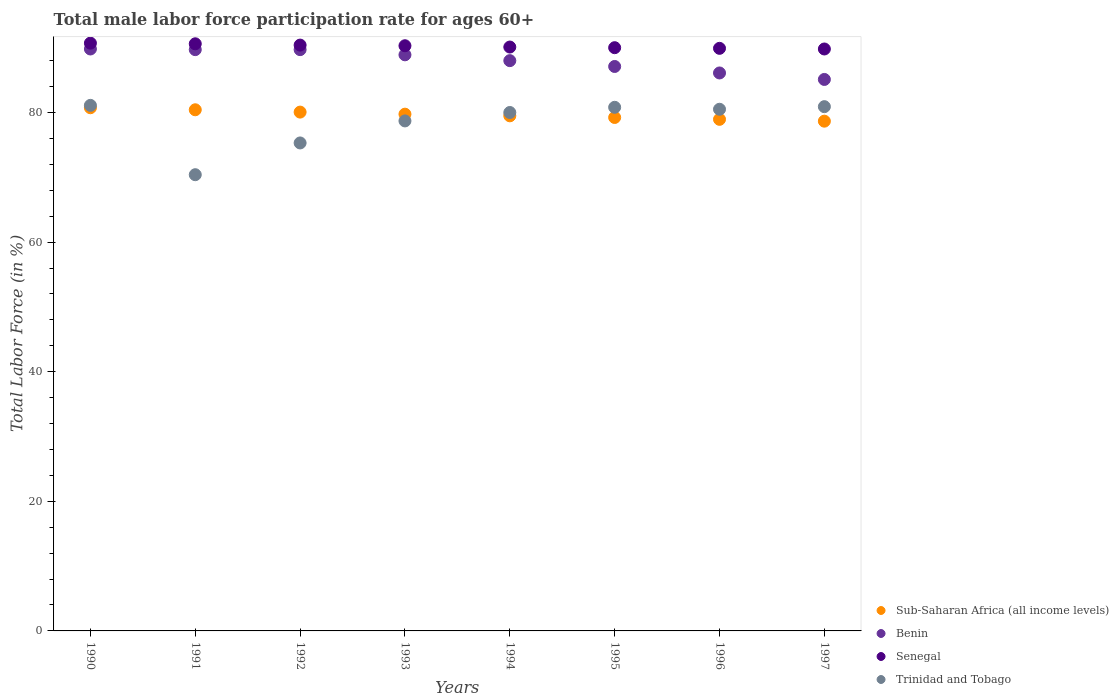Is the number of dotlines equal to the number of legend labels?
Make the answer very short. Yes. What is the male labor force participation rate in Benin in 1995?
Your answer should be compact. 87.1. Across all years, what is the maximum male labor force participation rate in Trinidad and Tobago?
Give a very brief answer. 81.1. Across all years, what is the minimum male labor force participation rate in Trinidad and Tobago?
Ensure brevity in your answer.  70.4. In which year was the male labor force participation rate in Sub-Saharan Africa (all income levels) maximum?
Offer a terse response. 1990. In which year was the male labor force participation rate in Trinidad and Tobago minimum?
Provide a succinct answer. 1991. What is the total male labor force participation rate in Trinidad and Tobago in the graph?
Make the answer very short. 627.7. What is the difference between the male labor force participation rate in Trinidad and Tobago in 1991 and that in 1992?
Make the answer very short. -4.9. What is the difference between the male labor force participation rate in Benin in 1991 and the male labor force participation rate in Trinidad and Tobago in 1990?
Your answer should be compact. 8.6. What is the average male labor force participation rate in Sub-Saharan Africa (all income levels) per year?
Keep it short and to the point. 79.66. In the year 1991, what is the difference between the male labor force participation rate in Sub-Saharan Africa (all income levels) and male labor force participation rate in Benin?
Ensure brevity in your answer.  -9.28. What is the ratio of the male labor force participation rate in Senegal in 1991 to that in 1992?
Your response must be concise. 1. Is the male labor force participation rate in Senegal in 1990 less than that in 1994?
Provide a succinct answer. No. What is the difference between the highest and the second highest male labor force participation rate in Benin?
Offer a very short reply. 0.1. What is the difference between the highest and the lowest male labor force participation rate in Benin?
Offer a very short reply. 4.7. In how many years, is the male labor force participation rate in Sub-Saharan Africa (all income levels) greater than the average male labor force participation rate in Sub-Saharan Africa (all income levels) taken over all years?
Offer a very short reply. 4. Is it the case that in every year, the sum of the male labor force participation rate in Benin and male labor force participation rate in Senegal  is greater than the male labor force participation rate in Trinidad and Tobago?
Keep it short and to the point. Yes. Is the male labor force participation rate in Sub-Saharan Africa (all income levels) strictly greater than the male labor force participation rate in Senegal over the years?
Offer a terse response. No. Is the male labor force participation rate in Trinidad and Tobago strictly less than the male labor force participation rate in Sub-Saharan Africa (all income levels) over the years?
Provide a succinct answer. No. How many dotlines are there?
Give a very brief answer. 4. How many years are there in the graph?
Make the answer very short. 8. What is the difference between two consecutive major ticks on the Y-axis?
Your response must be concise. 20. Are the values on the major ticks of Y-axis written in scientific E-notation?
Your answer should be compact. No. Does the graph contain any zero values?
Offer a very short reply. No. What is the title of the graph?
Make the answer very short. Total male labor force participation rate for ages 60+. What is the label or title of the X-axis?
Your response must be concise. Years. What is the label or title of the Y-axis?
Provide a short and direct response. Total Labor Force (in %). What is the Total Labor Force (in %) in Sub-Saharan Africa (all income levels) in 1990?
Give a very brief answer. 80.73. What is the Total Labor Force (in %) of Benin in 1990?
Provide a short and direct response. 89.8. What is the Total Labor Force (in %) in Senegal in 1990?
Offer a terse response. 90.7. What is the Total Labor Force (in %) of Trinidad and Tobago in 1990?
Make the answer very short. 81.1. What is the Total Labor Force (in %) of Sub-Saharan Africa (all income levels) in 1991?
Your answer should be very brief. 80.42. What is the Total Labor Force (in %) of Benin in 1991?
Offer a very short reply. 89.7. What is the Total Labor Force (in %) of Senegal in 1991?
Keep it short and to the point. 90.6. What is the Total Labor Force (in %) in Trinidad and Tobago in 1991?
Offer a terse response. 70.4. What is the Total Labor Force (in %) in Sub-Saharan Africa (all income levels) in 1992?
Ensure brevity in your answer.  80.06. What is the Total Labor Force (in %) in Benin in 1992?
Provide a succinct answer. 89.7. What is the Total Labor Force (in %) in Senegal in 1992?
Make the answer very short. 90.4. What is the Total Labor Force (in %) in Trinidad and Tobago in 1992?
Give a very brief answer. 75.3. What is the Total Labor Force (in %) of Sub-Saharan Africa (all income levels) in 1993?
Make the answer very short. 79.74. What is the Total Labor Force (in %) of Benin in 1993?
Offer a very short reply. 88.9. What is the Total Labor Force (in %) in Senegal in 1993?
Offer a very short reply. 90.3. What is the Total Labor Force (in %) of Trinidad and Tobago in 1993?
Offer a terse response. 78.7. What is the Total Labor Force (in %) of Sub-Saharan Africa (all income levels) in 1994?
Offer a very short reply. 79.49. What is the Total Labor Force (in %) in Benin in 1994?
Ensure brevity in your answer.  88. What is the Total Labor Force (in %) in Senegal in 1994?
Your answer should be very brief. 90.1. What is the Total Labor Force (in %) in Trinidad and Tobago in 1994?
Offer a very short reply. 80. What is the Total Labor Force (in %) in Sub-Saharan Africa (all income levels) in 1995?
Make the answer very short. 79.23. What is the Total Labor Force (in %) in Benin in 1995?
Provide a succinct answer. 87.1. What is the Total Labor Force (in %) in Trinidad and Tobago in 1995?
Make the answer very short. 80.8. What is the Total Labor Force (in %) in Sub-Saharan Africa (all income levels) in 1996?
Keep it short and to the point. 78.94. What is the Total Labor Force (in %) of Benin in 1996?
Offer a terse response. 86.1. What is the Total Labor Force (in %) in Senegal in 1996?
Provide a short and direct response. 89.9. What is the Total Labor Force (in %) of Trinidad and Tobago in 1996?
Offer a terse response. 80.5. What is the Total Labor Force (in %) of Sub-Saharan Africa (all income levels) in 1997?
Your response must be concise. 78.66. What is the Total Labor Force (in %) of Benin in 1997?
Provide a short and direct response. 85.1. What is the Total Labor Force (in %) in Senegal in 1997?
Give a very brief answer. 89.8. What is the Total Labor Force (in %) of Trinidad and Tobago in 1997?
Provide a succinct answer. 80.9. Across all years, what is the maximum Total Labor Force (in %) in Sub-Saharan Africa (all income levels)?
Your answer should be very brief. 80.73. Across all years, what is the maximum Total Labor Force (in %) of Benin?
Offer a very short reply. 89.8. Across all years, what is the maximum Total Labor Force (in %) of Senegal?
Offer a terse response. 90.7. Across all years, what is the maximum Total Labor Force (in %) of Trinidad and Tobago?
Keep it short and to the point. 81.1. Across all years, what is the minimum Total Labor Force (in %) of Sub-Saharan Africa (all income levels)?
Keep it short and to the point. 78.66. Across all years, what is the minimum Total Labor Force (in %) in Benin?
Keep it short and to the point. 85.1. Across all years, what is the minimum Total Labor Force (in %) in Senegal?
Keep it short and to the point. 89.8. Across all years, what is the minimum Total Labor Force (in %) of Trinidad and Tobago?
Your answer should be compact. 70.4. What is the total Total Labor Force (in %) of Sub-Saharan Africa (all income levels) in the graph?
Give a very brief answer. 637.27. What is the total Total Labor Force (in %) of Benin in the graph?
Keep it short and to the point. 704.4. What is the total Total Labor Force (in %) of Senegal in the graph?
Your response must be concise. 721.8. What is the total Total Labor Force (in %) in Trinidad and Tobago in the graph?
Give a very brief answer. 627.7. What is the difference between the Total Labor Force (in %) in Sub-Saharan Africa (all income levels) in 1990 and that in 1991?
Make the answer very short. 0.31. What is the difference between the Total Labor Force (in %) of Benin in 1990 and that in 1991?
Provide a succinct answer. 0.1. What is the difference between the Total Labor Force (in %) in Sub-Saharan Africa (all income levels) in 1990 and that in 1992?
Make the answer very short. 0.67. What is the difference between the Total Labor Force (in %) of Benin in 1990 and that in 1992?
Offer a very short reply. 0.1. What is the difference between the Total Labor Force (in %) in Senegal in 1990 and that in 1992?
Your answer should be very brief. 0.3. What is the difference between the Total Labor Force (in %) of Benin in 1990 and that in 1993?
Give a very brief answer. 0.9. What is the difference between the Total Labor Force (in %) in Senegal in 1990 and that in 1993?
Keep it short and to the point. 0.4. What is the difference between the Total Labor Force (in %) of Sub-Saharan Africa (all income levels) in 1990 and that in 1994?
Make the answer very short. 1.25. What is the difference between the Total Labor Force (in %) of Trinidad and Tobago in 1990 and that in 1994?
Your answer should be very brief. 1.1. What is the difference between the Total Labor Force (in %) of Sub-Saharan Africa (all income levels) in 1990 and that in 1995?
Make the answer very short. 1.5. What is the difference between the Total Labor Force (in %) in Benin in 1990 and that in 1995?
Provide a succinct answer. 2.7. What is the difference between the Total Labor Force (in %) in Senegal in 1990 and that in 1995?
Offer a very short reply. 0.7. What is the difference between the Total Labor Force (in %) in Sub-Saharan Africa (all income levels) in 1990 and that in 1996?
Your response must be concise. 1.79. What is the difference between the Total Labor Force (in %) in Benin in 1990 and that in 1996?
Provide a succinct answer. 3.7. What is the difference between the Total Labor Force (in %) of Senegal in 1990 and that in 1996?
Provide a succinct answer. 0.8. What is the difference between the Total Labor Force (in %) of Sub-Saharan Africa (all income levels) in 1990 and that in 1997?
Offer a terse response. 2.07. What is the difference between the Total Labor Force (in %) of Senegal in 1990 and that in 1997?
Offer a very short reply. 0.9. What is the difference between the Total Labor Force (in %) in Trinidad and Tobago in 1990 and that in 1997?
Your answer should be very brief. 0.2. What is the difference between the Total Labor Force (in %) of Sub-Saharan Africa (all income levels) in 1991 and that in 1992?
Provide a short and direct response. 0.36. What is the difference between the Total Labor Force (in %) of Benin in 1991 and that in 1992?
Your answer should be very brief. 0. What is the difference between the Total Labor Force (in %) in Senegal in 1991 and that in 1992?
Offer a terse response. 0.2. What is the difference between the Total Labor Force (in %) of Trinidad and Tobago in 1991 and that in 1992?
Your answer should be compact. -4.9. What is the difference between the Total Labor Force (in %) in Sub-Saharan Africa (all income levels) in 1991 and that in 1993?
Your response must be concise. 0.68. What is the difference between the Total Labor Force (in %) of Senegal in 1991 and that in 1993?
Keep it short and to the point. 0.3. What is the difference between the Total Labor Force (in %) of Trinidad and Tobago in 1991 and that in 1993?
Give a very brief answer. -8.3. What is the difference between the Total Labor Force (in %) of Sub-Saharan Africa (all income levels) in 1991 and that in 1994?
Make the answer very short. 0.93. What is the difference between the Total Labor Force (in %) of Trinidad and Tobago in 1991 and that in 1994?
Provide a short and direct response. -9.6. What is the difference between the Total Labor Force (in %) in Sub-Saharan Africa (all income levels) in 1991 and that in 1995?
Provide a short and direct response. 1.19. What is the difference between the Total Labor Force (in %) in Senegal in 1991 and that in 1995?
Your answer should be compact. 0.6. What is the difference between the Total Labor Force (in %) of Sub-Saharan Africa (all income levels) in 1991 and that in 1996?
Offer a very short reply. 1.48. What is the difference between the Total Labor Force (in %) in Benin in 1991 and that in 1996?
Your answer should be very brief. 3.6. What is the difference between the Total Labor Force (in %) in Sub-Saharan Africa (all income levels) in 1991 and that in 1997?
Your answer should be very brief. 1.76. What is the difference between the Total Labor Force (in %) in Senegal in 1991 and that in 1997?
Your answer should be compact. 0.8. What is the difference between the Total Labor Force (in %) of Trinidad and Tobago in 1991 and that in 1997?
Provide a succinct answer. -10.5. What is the difference between the Total Labor Force (in %) in Sub-Saharan Africa (all income levels) in 1992 and that in 1993?
Offer a terse response. 0.32. What is the difference between the Total Labor Force (in %) in Benin in 1992 and that in 1993?
Give a very brief answer. 0.8. What is the difference between the Total Labor Force (in %) in Sub-Saharan Africa (all income levels) in 1992 and that in 1994?
Provide a succinct answer. 0.57. What is the difference between the Total Labor Force (in %) in Benin in 1992 and that in 1994?
Make the answer very short. 1.7. What is the difference between the Total Labor Force (in %) of Senegal in 1992 and that in 1994?
Keep it short and to the point. 0.3. What is the difference between the Total Labor Force (in %) of Sub-Saharan Africa (all income levels) in 1992 and that in 1995?
Give a very brief answer. 0.83. What is the difference between the Total Labor Force (in %) of Senegal in 1992 and that in 1995?
Offer a very short reply. 0.4. What is the difference between the Total Labor Force (in %) of Trinidad and Tobago in 1992 and that in 1995?
Give a very brief answer. -5.5. What is the difference between the Total Labor Force (in %) of Sub-Saharan Africa (all income levels) in 1992 and that in 1996?
Provide a short and direct response. 1.12. What is the difference between the Total Labor Force (in %) in Senegal in 1992 and that in 1996?
Your answer should be very brief. 0.5. What is the difference between the Total Labor Force (in %) of Trinidad and Tobago in 1992 and that in 1996?
Offer a terse response. -5.2. What is the difference between the Total Labor Force (in %) in Sub-Saharan Africa (all income levels) in 1992 and that in 1997?
Your answer should be very brief. 1.4. What is the difference between the Total Labor Force (in %) in Sub-Saharan Africa (all income levels) in 1993 and that in 1994?
Your response must be concise. 0.25. What is the difference between the Total Labor Force (in %) of Senegal in 1993 and that in 1994?
Offer a very short reply. 0.2. What is the difference between the Total Labor Force (in %) of Sub-Saharan Africa (all income levels) in 1993 and that in 1995?
Give a very brief answer. 0.51. What is the difference between the Total Labor Force (in %) in Benin in 1993 and that in 1995?
Your response must be concise. 1.8. What is the difference between the Total Labor Force (in %) in Senegal in 1993 and that in 1995?
Provide a short and direct response. 0.3. What is the difference between the Total Labor Force (in %) of Trinidad and Tobago in 1993 and that in 1995?
Your answer should be compact. -2.1. What is the difference between the Total Labor Force (in %) in Sub-Saharan Africa (all income levels) in 1993 and that in 1996?
Ensure brevity in your answer.  0.8. What is the difference between the Total Labor Force (in %) in Senegal in 1993 and that in 1996?
Make the answer very short. 0.4. What is the difference between the Total Labor Force (in %) in Sub-Saharan Africa (all income levels) in 1993 and that in 1997?
Ensure brevity in your answer.  1.08. What is the difference between the Total Labor Force (in %) of Trinidad and Tobago in 1993 and that in 1997?
Provide a succinct answer. -2.2. What is the difference between the Total Labor Force (in %) in Sub-Saharan Africa (all income levels) in 1994 and that in 1995?
Ensure brevity in your answer.  0.25. What is the difference between the Total Labor Force (in %) in Benin in 1994 and that in 1995?
Offer a terse response. 0.9. What is the difference between the Total Labor Force (in %) of Trinidad and Tobago in 1994 and that in 1995?
Keep it short and to the point. -0.8. What is the difference between the Total Labor Force (in %) in Sub-Saharan Africa (all income levels) in 1994 and that in 1996?
Your answer should be very brief. 0.54. What is the difference between the Total Labor Force (in %) in Benin in 1994 and that in 1996?
Your answer should be compact. 1.9. What is the difference between the Total Labor Force (in %) of Senegal in 1994 and that in 1996?
Ensure brevity in your answer.  0.2. What is the difference between the Total Labor Force (in %) of Trinidad and Tobago in 1994 and that in 1996?
Offer a terse response. -0.5. What is the difference between the Total Labor Force (in %) of Sub-Saharan Africa (all income levels) in 1994 and that in 1997?
Give a very brief answer. 0.82. What is the difference between the Total Labor Force (in %) in Benin in 1994 and that in 1997?
Give a very brief answer. 2.9. What is the difference between the Total Labor Force (in %) of Senegal in 1994 and that in 1997?
Your answer should be very brief. 0.3. What is the difference between the Total Labor Force (in %) of Trinidad and Tobago in 1994 and that in 1997?
Offer a very short reply. -0.9. What is the difference between the Total Labor Force (in %) in Sub-Saharan Africa (all income levels) in 1995 and that in 1996?
Provide a short and direct response. 0.29. What is the difference between the Total Labor Force (in %) in Senegal in 1995 and that in 1996?
Keep it short and to the point. 0.1. What is the difference between the Total Labor Force (in %) in Sub-Saharan Africa (all income levels) in 1995 and that in 1997?
Your answer should be very brief. 0.57. What is the difference between the Total Labor Force (in %) of Benin in 1995 and that in 1997?
Offer a very short reply. 2. What is the difference between the Total Labor Force (in %) of Trinidad and Tobago in 1995 and that in 1997?
Make the answer very short. -0.1. What is the difference between the Total Labor Force (in %) of Sub-Saharan Africa (all income levels) in 1996 and that in 1997?
Provide a succinct answer. 0.28. What is the difference between the Total Labor Force (in %) in Benin in 1996 and that in 1997?
Ensure brevity in your answer.  1. What is the difference between the Total Labor Force (in %) in Trinidad and Tobago in 1996 and that in 1997?
Provide a succinct answer. -0.4. What is the difference between the Total Labor Force (in %) of Sub-Saharan Africa (all income levels) in 1990 and the Total Labor Force (in %) of Benin in 1991?
Give a very brief answer. -8.97. What is the difference between the Total Labor Force (in %) in Sub-Saharan Africa (all income levels) in 1990 and the Total Labor Force (in %) in Senegal in 1991?
Make the answer very short. -9.87. What is the difference between the Total Labor Force (in %) in Sub-Saharan Africa (all income levels) in 1990 and the Total Labor Force (in %) in Trinidad and Tobago in 1991?
Offer a very short reply. 10.33. What is the difference between the Total Labor Force (in %) of Benin in 1990 and the Total Labor Force (in %) of Trinidad and Tobago in 1991?
Provide a succinct answer. 19.4. What is the difference between the Total Labor Force (in %) in Senegal in 1990 and the Total Labor Force (in %) in Trinidad and Tobago in 1991?
Your answer should be compact. 20.3. What is the difference between the Total Labor Force (in %) in Sub-Saharan Africa (all income levels) in 1990 and the Total Labor Force (in %) in Benin in 1992?
Keep it short and to the point. -8.97. What is the difference between the Total Labor Force (in %) in Sub-Saharan Africa (all income levels) in 1990 and the Total Labor Force (in %) in Senegal in 1992?
Ensure brevity in your answer.  -9.67. What is the difference between the Total Labor Force (in %) of Sub-Saharan Africa (all income levels) in 1990 and the Total Labor Force (in %) of Trinidad and Tobago in 1992?
Provide a short and direct response. 5.43. What is the difference between the Total Labor Force (in %) in Benin in 1990 and the Total Labor Force (in %) in Senegal in 1992?
Keep it short and to the point. -0.6. What is the difference between the Total Labor Force (in %) of Sub-Saharan Africa (all income levels) in 1990 and the Total Labor Force (in %) of Benin in 1993?
Give a very brief answer. -8.17. What is the difference between the Total Labor Force (in %) of Sub-Saharan Africa (all income levels) in 1990 and the Total Labor Force (in %) of Senegal in 1993?
Your answer should be compact. -9.57. What is the difference between the Total Labor Force (in %) of Sub-Saharan Africa (all income levels) in 1990 and the Total Labor Force (in %) of Trinidad and Tobago in 1993?
Your response must be concise. 2.03. What is the difference between the Total Labor Force (in %) in Benin in 1990 and the Total Labor Force (in %) in Senegal in 1993?
Offer a terse response. -0.5. What is the difference between the Total Labor Force (in %) of Sub-Saharan Africa (all income levels) in 1990 and the Total Labor Force (in %) of Benin in 1994?
Offer a very short reply. -7.27. What is the difference between the Total Labor Force (in %) of Sub-Saharan Africa (all income levels) in 1990 and the Total Labor Force (in %) of Senegal in 1994?
Your answer should be compact. -9.37. What is the difference between the Total Labor Force (in %) of Sub-Saharan Africa (all income levels) in 1990 and the Total Labor Force (in %) of Trinidad and Tobago in 1994?
Your answer should be very brief. 0.73. What is the difference between the Total Labor Force (in %) of Benin in 1990 and the Total Labor Force (in %) of Senegal in 1994?
Provide a short and direct response. -0.3. What is the difference between the Total Labor Force (in %) of Sub-Saharan Africa (all income levels) in 1990 and the Total Labor Force (in %) of Benin in 1995?
Ensure brevity in your answer.  -6.37. What is the difference between the Total Labor Force (in %) of Sub-Saharan Africa (all income levels) in 1990 and the Total Labor Force (in %) of Senegal in 1995?
Provide a succinct answer. -9.27. What is the difference between the Total Labor Force (in %) in Sub-Saharan Africa (all income levels) in 1990 and the Total Labor Force (in %) in Trinidad and Tobago in 1995?
Offer a terse response. -0.07. What is the difference between the Total Labor Force (in %) of Benin in 1990 and the Total Labor Force (in %) of Trinidad and Tobago in 1995?
Your answer should be compact. 9. What is the difference between the Total Labor Force (in %) in Senegal in 1990 and the Total Labor Force (in %) in Trinidad and Tobago in 1995?
Provide a succinct answer. 9.9. What is the difference between the Total Labor Force (in %) of Sub-Saharan Africa (all income levels) in 1990 and the Total Labor Force (in %) of Benin in 1996?
Offer a terse response. -5.37. What is the difference between the Total Labor Force (in %) of Sub-Saharan Africa (all income levels) in 1990 and the Total Labor Force (in %) of Senegal in 1996?
Provide a succinct answer. -9.17. What is the difference between the Total Labor Force (in %) in Sub-Saharan Africa (all income levels) in 1990 and the Total Labor Force (in %) in Trinidad and Tobago in 1996?
Provide a short and direct response. 0.23. What is the difference between the Total Labor Force (in %) in Benin in 1990 and the Total Labor Force (in %) in Senegal in 1996?
Your answer should be very brief. -0.1. What is the difference between the Total Labor Force (in %) of Senegal in 1990 and the Total Labor Force (in %) of Trinidad and Tobago in 1996?
Provide a succinct answer. 10.2. What is the difference between the Total Labor Force (in %) in Sub-Saharan Africa (all income levels) in 1990 and the Total Labor Force (in %) in Benin in 1997?
Offer a terse response. -4.37. What is the difference between the Total Labor Force (in %) of Sub-Saharan Africa (all income levels) in 1990 and the Total Labor Force (in %) of Senegal in 1997?
Offer a terse response. -9.07. What is the difference between the Total Labor Force (in %) of Sub-Saharan Africa (all income levels) in 1990 and the Total Labor Force (in %) of Trinidad and Tobago in 1997?
Provide a succinct answer. -0.17. What is the difference between the Total Labor Force (in %) in Benin in 1990 and the Total Labor Force (in %) in Senegal in 1997?
Your answer should be compact. 0. What is the difference between the Total Labor Force (in %) of Senegal in 1990 and the Total Labor Force (in %) of Trinidad and Tobago in 1997?
Make the answer very short. 9.8. What is the difference between the Total Labor Force (in %) in Sub-Saharan Africa (all income levels) in 1991 and the Total Labor Force (in %) in Benin in 1992?
Offer a terse response. -9.28. What is the difference between the Total Labor Force (in %) of Sub-Saharan Africa (all income levels) in 1991 and the Total Labor Force (in %) of Senegal in 1992?
Your response must be concise. -9.98. What is the difference between the Total Labor Force (in %) in Sub-Saharan Africa (all income levels) in 1991 and the Total Labor Force (in %) in Trinidad and Tobago in 1992?
Ensure brevity in your answer.  5.12. What is the difference between the Total Labor Force (in %) in Benin in 1991 and the Total Labor Force (in %) in Senegal in 1992?
Keep it short and to the point. -0.7. What is the difference between the Total Labor Force (in %) of Sub-Saharan Africa (all income levels) in 1991 and the Total Labor Force (in %) of Benin in 1993?
Make the answer very short. -8.48. What is the difference between the Total Labor Force (in %) in Sub-Saharan Africa (all income levels) in 1991 and the Total Labor Force (in %) in Senegal in 1993?
Offer a very short reply. -9.88. What is the difference between the Total Labor Force (in %) of Sub-Saharan Africa (all income levels) in 1991 and the Total Labor Force (in %) of Trinidad and Tobago in 1993?
Provide a short and direct response. 1.72. What is the difference between the Total Labor Force (in %) in Benin in 1991 and the Total Labor Force (in %) in Senegal in 1993?
Make the answer very short. -0.6. What is the difference between the Total Labor Force (in %) in Benin in 1991 and the Total Labor Force (in %) in Trinidad and Tobago in 1993?
Give a very brief answer. 11. What is the difference between the Total Labor Force (in %) of Senegal in 1991 and the Total Labor Force (in %) of Trinidad and Tobago in 1993?
Offer a very short reply. 11.9. What is the difference between the Total Labor Force (in %) in Sub-Saharan Africa (all income levels) in 1991 and the Total Labor Force (in %) in Benin in 1994?
Provide a succinct answer. -7.58. What is the difference between the Total Labor Force (in %) of Sub-Saharan Africa (all income levels) in 1991 and the Total Labor Force (in %) of Senegal in 1994?
Make the answer very short. -9.68. What is the difference between the Total Labor Force (in %) in Sub-Saharan Africa (all income levels) in 1991 and the Total Labor Force (in %) in Trinidad and Tobago in 1994?
Give a very brief answer. 0.42. What is the difference between the Total Labor Force (in %) in Benin in 1991 and the Total Labor Force (in %) in Trinidad and Tobago in 1994?
Give a very brief answer. 9.7. What is the difference between the Total Labor Force (in %) of Senegal in 1991 and the Total Labor Force (in %) of Trinidad and Tobago in 1994?
Keep it short and to the point. 10.6. What is the difference between the Total Labor Force (in %) of Sub-Saharan Africa (all income levels) in 1991 and the Total Labor Force (in %) of Benin in 1995?
Your response must be concise. -6.68. What is the difference between the Total Labor Force (in %) in Sub-Saharan Africa (all income levels) in 1991 and the Total Labor Force (in %) in Senegal in 1995?
Provide a short and direct response. -9.58. What is the difference between the Total Labor Force (in %) in Sub-Saharan Africa (all income levels) in 1991 and the Total Labor Force (in %) in Trinidad and Tobago in 1995?
Offer a terse response. -0.38. What is the difference between the Total Labor Force (in %) in Benin in 1991 and the Total Labor Force (in %) in Senegal in 1995?
Offer a terse response. -0.3. What is the difference between the Total Labor Force (in %) in Senegal in 1991 and the Total Labor Force (in %) in Trinidad and Tobago in 1995?
Your answer should be very brief. 9.8. What is the difference between the Total Labor Force (in %) of Sub-Saharan Africa (all income levels) in 1991 and the Total Labor Force (in %) of Benin in 1996?
Your answer should be compact. -5.68. What is the difference between the Total Labor Force (in %) of Sub-Saharan Africa (all income levels) in 1991 and the Total Labor Force (in %) of Senegal in 1996?
Give a very brief answer. -9.48. What is the difference between the Total Labor Force (in %) of Sub-Saharan Africa (all income levels) in 1991 and the Total Labor Force (in %) of Trinidad and Tobago in 1996?
Offer a very short reply. -0.08. What is the difference between the Total Labor Force (in %) in Sub-Saharan Africa (all income levels) in 1991 and the Total Labor Force (in %) in Benin in 1997?
Provide a succinct answer. -4.68. What is the difference between the Total Labor Force (in %) in Sub-Saharan Africa (all income levels) in 1991 and the Total Labor Force (in %) in Senegal in 1997?
Make the answer very short. -9.38. What is the difference between the Total Labor Force (in %) in Sub-Saharan Africa (all income levels) in 1991 and the Total Labor Force (in %) in Trinidad and Tobago in 1997?
Your answer should be very brief. -0.48. What is the difference between the Total Labor Force (in %) in Benin in 1991 and the Total Labor Force (in %) in Senegal in 1997?
Give a very brief answer. -0.1. What is the difference between the Total Labor Force (in %) of Senegal in 1991 and the Total Labor Force (in %) of Trinidad and Tobago in 1997?
Offer a terse response. 9.7. What is the difference between the Total Labor Force (in %) of Sub-Saharan Africa (all income levels) in 1992 and the Total Labor Force (in %) of Benin in 1993?
Offer a very short reply. -8.84. What is the difference between the Total Labor Force (in %) of Sub-Saharan Africa (all income levels) in 1992 and the Total Labor Force (in %) of Senegal in 1993?
Ensure brevity in your answer.  -10.24. What is the difference between the Total Labor Force (in %) of Sub-Saharan Africa (all income levels) in 1992 and the Total Labor Force (in %) of Trinidad and Tobago in 1993?
Make the answer very short. 1.36. What is the difference between the Total Labor Force (in %) in Benin in 1992 and the Total Labor Force (in %) in Senegal in 1993?
Ensure brevity in your answer.  -0.6. What is the difference between the Total Labor Force (in %) of Benin in 1992 and the Total Labor Force (in %) of Trinidad and Tobago in 1993?
Offer a very short reply. 11. What is the difference between the Total Labor Force (in %) in Senegal in 1992 and the Total Labor Force (in %) in Trinidad and Tobago in 1993?
Keep it short and to the point. 11.7. What is the difference between the Total Labor Force (in %) in Sub-Saharan Africa (all income levels) in 1992 and the Total Labor Force (in %) in Benin in 1994?
Keep it short and to the point. -7.94. What is the difference between the Total Labor Force (in %) of Sub-Saharan Africa (all income levels) in 1992 and the Total Labor Force (in %) of Senegal in 1994?
Your answer should be compact. -10.04. What is the difference between the Total Labor Force (in %) in Sub-Saharan Africa (all income levels) in 1992 and the Total Labor Force (in %) in Trinidad and Tobago in 1994?
Your answer should be compact. 0.06. What is the difference between the Total Labor Force (in %) of Senegal in 1992 and the Total Labor Force (in %) of Trinidad and Tobago in 1994?
Your response must be concise. 10.4. What is the difference between the Total Labor Force (in %) in Sub-Saharan Africa (all income levels) in 1992 and the Total Labor Force (in %) in Benin in 1995?
Offer a terse response. -7.04. What is the difference between the Total Labor Force (in %) in Sub-Saharan Africa (all income levels) in 1992 and the Total Labor Force (in %) in Senegal in 1995?
Offer a very short reply. -9.94. What is the difference between the Total Labor Force (in %) in Sub-Saharan Africa (all income levels) in 1992 and the Total Labor Force (in %) in Trinidad and Tobago in 1995?
Give a very brief answer. -0.74. What is the difference between the Total Labor Force (in %) in Sub-Saharan Africa (all income levels) in 1992 and the Total Labor Force (in %) in Benin in 1996?
Give a very brief answer. -6.04. What is the difference between the Total Labor Force (in %) in Sub-Saharan Africa (all income levels) in 1992 and the Total Labor Force (in %) in Senegal in 1996?
Provide a short and direct response. -9.84. What is the difference between the Total Labor Force (in %) in Sub-Saharan Africa (all income levels) in 1992 and the Total Labor Force (in %) in Trinidad and Tobago in 1996?
Offer a terse response. -0.44. What is the difference between the Total Labor Force (in %) of Benin in 1992 and the Total Labor Force (in %) of Trinidad and Tobago in 1996?
Offer a terse response. 9.2. What is the difference between the Total Labor Force (in %) of Sub-Saharan Africa (all income levels) in 1992 and the Total Labor Force (in %) of Benin in 1997?
Your answer should be compact. -5.04. What is the difference between the Total Labor Force (in %) of Sub-Saharan Africa (all income levels) in 1992 and the Total Labor Force (in %) of Senegal in 1997?
Your response must be concise. -9.74. What is the difference between the Total Labor Force (in %) of Sub-Saharan Africa (all income levels) in 1992 and the Total Labor Force (in %) of Trinidad and Tobago in 1997?
Provide a short and direct response. -0.84. What is the difference between the Total Labor Force (in %) in Benin in 1992 and the Total Labor Force (in %) in Trinidad and Tobago in 1997?
Provide a succinct answer. 8.8. What is the difference between the Total Labor Force (in %) of Sub-Saharan Africa (all income levels) in 1993 and the Total Labor Force (in %) of Benin in 1994?
Your answer should be very brief. -8.26. What is the difference between the Total Labor Force (in %) of Sub-Saharan Africa (all income levels) in 1993 and the Total Labor Force (in %) of Senegal in 1994?
Offer a very short reply. -10.36. What is the difference between the Total Labor Force (in %) of Sub-Saharan Africa (all income levels) in 1993 and the Total Labor Force (in %) of Trinidad and Tobago in 1994?
Provide a short and direct response. -0.26. What is the difference between the Total Labor Force (in %) in Benin in 1993 and the Total Labor Force (in %) in Senegal in 1994?
Provide a succinct answer. -1.2. What is the difference between the Total Labor Force (in %) of Benin in 1993 and the Total Labor Force (in %) of Trinidad and Tobago in 1994?
Offer a terse response. 8.9. What is the difference between the Total Labor Force (in %) in Sub-Saharan Africa (all income levels) in 1993 and the Total Labor Force (in %) in Benin in 1995?
Offer a very short reply. -7.36. What is the difference between the Total Labor Force (in %) of Sub-Saharan Africa (all income levels) in 1993 and the Total Labor Force (in %) of Senegal in 1995?
Offer a very short reply. -10.26. What is the difference between the Total Labor Force (in %) of Sub-Saharan Africa (all income levels) in 1993 and the Total Labor Force (in %) of Trinidad and Tobago in 1995?
Ensure brevity in your answer.  -1.06. What is the difference between the Total Labor Force (in %) of Sub-Saharan Africa (all income levels) in 1993 and the Total Labor Force (in %) of Benin in 1996?
Offer a very short reply. -6.36. What is the difference between the Total Labor Force (in %) of Sub-Saharan Africa (all income levels) in 1993 and the Total Labor Force (in %) of Senegal in 1996?
Provide a short and direct response. -10.16. What is the difference between the Total Labor Force (in %) in Sub-Saharan Africa (all income levels) in 1993 and the Total Labor Force (in %) in Trinidad and Tobago in 1996?
Your answer should be very brief. -0.76. What is the difference between the Total Labor Force (in %) of Benin in 1993 and the Total Labor Force (in %) of Senegal in 1996?
Your answer should be very brief. -1. What is the difference between the Total Labor Force (in %) of Benin in 1993 and the Total Labor Force (in %) of Trinidad and Tobago in 1996?
Offer a very short reply. 8.4. What is the difference between the Total Labor Force (in %) in Sub-Saharan Africa (all income levels) in 1993 and the Total Labor Force (in %) in Benin in 1997?
Give a very brief answer. -5.36. What is the difference between the Total Labor Force (in %) of Sub-Saharan Africa (all income levels) in 1993 and the Total Labor Force (in %) of Senegal in 1997?
Your answer should be very brief. -10.06. What is the difference between the Total Labor Force (in %) in Sub-Saharan Africa (all income levels) in 1993 and the Total Labor Force (in %) in Trinidad and Tobago in 1997?
Offer a very short reply. -1.16. What is the difference between the Total Labor Force (in %) of Benin in 1993 and the Total Labor Force (in %) of Senegal in 1997?
Give a very brief answer. -0.9. What is the difference between the Total Labor Force (in %) in Senegal in 1993 and the Total Labor Force (in %) in Trinidad and Tobago in 1997?
Your answer should be very brief. 9.4. What is the difference between the Total Labor Force (in %) in Sub-Saharan Africa (all income levels) in 1994 and the Total Labor Force (in %) in Benin in 1995?
Offer a very short reply. -7.61. What is the difference between the Total Labor Force (in %) of Sub-Saharan Africa (all income levels) in 1994 and the Total Labor Force (in %) of Senegal in 1995?
Your response must be concise. -10.51. What is the difference between the Total Labor Force (in %) in Sub-Saharan Africa (all income levels) in 1994 and the Total Labor Force (in %) in Trinidad and Tobago in 1995?
Keep it short and to the point. -1.31. What is the difference between the Total Labor Force (in %) in Senegal in 1994 and the Total Labor Force (in %) in Trinidad and Tobago in 1995?
Keep it short and to the point. 9.3. What is the difference between the Total Labor Force (in %) in Sub-Saharan Africa (all income levels) in 1994 and the Total Labor Force (in %) in Benin in 1996?
Provide a succinct answer. -6.61. What is the difference between the Total Labor Force (in %) in Sub-Saharan Africa (all income levels) in 1994 and the Total Labor Force (in %) in Senegal in 1996?
Your response must be concise. -10.41. What is the difference between the Total Labor Force (in %) of Sub-Saharan Africa (all income levels) in 1994 and the Total Labor Force (in %) of Trinidad and Tobago in 1996?
Your answer should be compact. -1.01. What is the difference between the Total Labor Force (in %) of Benin in 1994 and the Total Labor Force (in %) of Trinidad and Tobago in 1996?
Provide a short and direct response. 7.5. What is the difference between the Total Labor Force (in %) of Sub-Saharan Africa (all income levels) in 1994 and the Total Labor Force (in %) of Benin in 1997?
Your answer should be compact. -5.61. What is the difference between the Total Labor Force (in %) of Sub-Saharan Africa (all income levels) in 1994 and the Total Labor Force (in %) of Senegal in 1997?
Ensure brevity in your answer.  -10.31. What is the difference between the Total Labor Force (in %) in Sub-Saharan Africa (all income levels) in 1994 and the Total Labor Force (in %) in Trinidad and Tobago in 1997?
Your answer should be very brief. -1.41. What is the difference between the Total Labor Force (in %) in Benin in 1994 and the Total Labor Force (in %) in Trinidad and Tobago in 1997?
Provide a short and direct response. 7.1. What is the difference between the Total Labor Force (in %) in Senegal in 1994 and the Total Labor Force (in %) in Trinidad and Tobago in 1997?
Give a very brief answer. 9.2. What is the difference between the Total Labor Force (in %) in Sub-Saharan Africa (all income levels) in 1995 and the Total Labor Force (in %) in Benin in 1996?
Provide a short and direct response. -6.87. What is the difference between the Total Labor Force (in %) of Sub-Saharan Africa (all income levels) in 1995 and the Total Labor Force (in %) of Senegal in 1996?
Provide a short and direct response. -10.67. What is the difference between the Total Labor Force (in %) in Sub-Saharan Africa (all income levels) in 1995 and the Total Labor Force (in %) in Trinidad and Tobago in 1996?
Your answer should be very brief. -1.27. What is the difference between the Total Labor Force (in %) of Sub-Saharan Africa (all income levels) in 1995 and the Total Labor Force (in %) of Benin in 1997?
Ensure brevity in your answer.  -5.87. What is the difference between the Total Labor Force (in %) in Sub-Saharan Africa (all income levels) in 1995 and the Total Labor Force (in %) in Senegal in 1997?
Your answer should be very brief. -10.57. What is the difference between the Total Labor Force (in %) of Sub-Saharan Africa (all income levels) in 1995 and the Total Labor Force (in %) of Trinidad and Tobago in 1997?
Make the answer very short. -1.67. What is the difference between the Total Labor Force (in %) in Benin in 1995 and the Total Labor Force (in %) in Senegal in 1997?
Your response must be concise. -2.7. What is the difference between the Total Labor Force (in %) of Senegal in 1995 and the Total Labor Force (in %) of Trinidad and Tobago in 1997?
Provide a succinct answer. 9.1. What is the difference between the Total Labor Force (in %) in Sub-Saharan Africa (all income levels) in 1996 and the Total Labor Force (in %) in Benin in 1997?
Your answer should be compact. -6.16. What is the difference between the Total Labor Force (in %) of Sub-Saharan Africa (all income levels) in 1996 and the Total Labor Force (in %) of Senegal in 1997?
Your answer should be compact. -10.86. What is the difference between the Total Labor Force (in %) in Sub-Saharan Africa (all income levels) in 1996 and the Total Labor Force (in %) in Trinidad and Tobago in 1997?
Ensure brevity in your answer.  -1.96. What is the difference between the Total Labor Force (in %) of Benin in 1996 and the Total Labor Force (in %) of Senegal in 1997?
Your answer should be compact. -3.7. What is the difference between the Total Labor Force (in %) of Benin in 1996 and the Total Labor Force (in %) of Trinidad and Tobago in 1997?
Offer a terse response. 5.2. What is the difference between the Total Labor Force (in %) of Senegal in 1996 and the Total Labor Force (in %) of Trinidad and Tobago in 1997?
Ensure brevity in your answer.  9. What is the average Total Labor Force (in %) of Sub-Saharan Africa (all income levels) per year?
Keep it short and to the point. 79.66. What is the average Total Labor Force (in %) in Benin per year?
Give a very brief answer. 88.05. What is the average Total Labor Force (in %) in Senegal per year?
Offer a very short reply. 90.22. What is the average Total Labor Force (in %) in Trinidad and Tobago per year?
Offer a very short reply. 78.46. In the year 1990, what is the difference between the Total Labor Force (in %) in Sub-Saharan Africa (all income levels) and Total Labor Force (in %) in Benin?
Provide a short and direct response. -9.07. In the year 1990, what is the difference between the Total Labor Force (in %) in Sub-Saharan Africa (all income levels) and Total Labor Force (in %) in Senegal?
Offer a very short reply. -9.97. In the year 1990, what is the difference between the Total Labor Force (in %) of Sub-Saharan Africa (all income levels) and Total Labor Force (in %) of Trinidad and Tobago?
Keep it short and to the point. -0.37. In the year 1990, what is the difference between the Total Labor Force (in %) of Benin and Total Labor Force (in %) of Senegal?
Ensure brevity in your answer.  -0.9. In the year 1990, what is the difference between the Total Labor Force (in %) of Benin and Total Labor Force (in %) of Trinidad and Tobago?
Offer a very short reply. 8.7. In the year 1991, what is the difference between the Total Labor Force (in %) of Sub-Saharan Africa (all income levels) and Total Labor Force (in %) of Benin?
Provide a succinct answer. -9.28. In the year 1991, what is the difference between the Total Labor Force (in %) of Sub-Saharan Africa (all income levels) and Total Labor Force (in %) of Senegal?
Make the answer very short. -10.18. In the year 1991, what is the difference between the Total Labor Force (in %) in Sub-Saharan Africa (all income levels) and Total Labor Force (in %) in Trinidad and Tobago?
Give a very brief answer. 10.02. In the year 1991, what is the difference between the Total Labor Force (in %) in Benin and Total Labor Force (in %) in Trinidad and Tobago?
Make the answer very short. 19.3. In the year 1991, what is the difference between the Total Labor Force (in %) in Senegal and Total Labor Force (in %) in Trinidad and Tobago?
Your response must be concise. 20.2. In the year 1992, what is the difference between the Total Labor Force (in %) in Sub-Saharan Africa (all income levels) and Total Labor Force (in %) in Benin?
Your response must be concise. -9.64. In the year 1992, what is the difference between the Total Labor Force (in %) in Sub-Saharan Africa (all income levels) and Total Labor Force (in %) in Senegal?
Keep it short and to the point. -10.34. In the year 1992, what is the difference between the Total Labor Force (in %) in Sub-Saharan Africa (all income levels) and Total Labor Force (in %) in Trinidad and Tobago?
Keep it short and to the point. 4.76. In the year 1992, what is the difference between the Total Labor Force (in %) in Benin and Total Labor Force (in %) in Trinidad and Tobago?
Give a very brief answer. 14.4. In the year 1992, what is the difference between the Total Labor Force (in %) of Senegal and Total Labor Force (in %) of Trinidad and Tobago?
Ensure brevity in your answer.  15.1. In the year 1993, what is the difference between the Total Labor Force (in %) in Sub-Saharan Africa (all income levels) and Total Labor Force (in %) in Benin?
Your answer should be very brief. -9.16. In the year 1993, what is the difference between the Total Labor Force (in %) of Sub-Saharan Africa (all income levels) and Total Labor Force (in %) of Senegal?
Give a very brief answer. -10.56. In the year 1993, what is the difference between the Total Labor Force (in %) in Sub-Saharan Africa (all income levels) and Total Labor Force (in %) in Trinidad and Tobago?
Offer a terse response. 1.04. In the year 1993, what is the difference between the Total Labor Force (in %) in Benin and Total Labor Force (in %) in Trinidad and Tobago?
Offer a terse response. 10.2. In the year 1994, what is the difference between the Total Labor Force (in %) of Sub-Saharan Africa (all income levels) and Total Labor Force (in %) of Benin?
Give a very brief answer. -8.51. In the year 1994, what is the difference between the Total Labor Force (in %) in Sub-Saharan Africa (all income levels) and Total Labor Force (in %) in Senegal?
Provide a succinct answer. -10.61. In the year 1994, what is the difference between the Total Labor Force (in %) of Sub-Saharan Africa (all income levels) and Total Labor Force (in %) of Trinidad and Tobago?
Your answer should be very brief. -0.51. In the year 1994, what is the difference between the Total Labor Force (in %) in Benin and Total Labor Force (in %) in Trinidad and Tobago?
Offer a terse response. 8. In the year 1994, what is the difference between the Total Labor Force (in %) of Senegal and Total Labor Force (in %) of Trinidad and Tobago?
Your answer should be very brief. 10.1. In the year 1995, what is the difference between the Total Labor Force (in %) of Sub-Saharan Africa (all income levels) and Total Labor Force (in %) of Benin?
Your answer should be compact. -7.87. In the year 1995, what is the difference between the Total Labor Force (in %) of Sub-Saharan Africa (all income levels) and Total Labor Force (in %) of Senegal?
Your answer should be very brief. -10.77. In the year 1995, what is the difference between the Total Labor Force (in %) of Sub-Saharan Africa (all income levels) and Total Labor Force (in %) of Trinidad and Tobago?
Your answer should be very brief. -1.57. In the year 1995, what is the difference between the Total Labor Force (in %) in Benin and Total Labor Force (in %) in Senegal?
Provide a succinct answer. -2.9. In the year 1995, what is the difference between the Total Labor Force (in %) in Senegal and Total Labor Force (in %) in Trinidad and Tobago?
Your answer should be very brief. 9.2. In the year 1996, what is the difference between the Total Labor Force (in %) of Sub-Saharan Africa (all income levels) and Total Labor Force (in %) of Benin?
Provide a succinct answer. -7.16. In the year 1996, what is the difference between the Total Labor Force (in %) in Sub-Saharan Africa (all income levels) and Total Labor Force (in %) in Senegal?
Your answer should be compact. -10.96. In the year 1996, what is the difference between the Total Labor Force (in %) in Sub-Saharan Africa (all income levels) and Total Labor Force (in %) in Trinidad and Tobago?
Provide a succinct answer. -1.56. In the year 1996, what is the difference between the Total Labor Force (in %) of Benin and Total Labor Force (in %) of Senegal?
Give a very brief answer. -3.8. In the year 1996, what is the difference between the Total Labor Force (in %) in Benin and Total Labor Force (in %) in Trinidad and Tobago?
Your response must be concise. 5.6. In the year 1996, what is the difference between the Total Labor Force (in %) of Senegal and Total Labor Force (in %) of Trinidad and Tobago?
Your answer should be compact. 9.4. In the year 1997, what is the difference between the Total Labor Force (in %) of Sub-Saharan Africa (all income levels) and Total Labor Force (in %) of Benin?
Make the answer very short. -6.44. In the year 1997, what is the difference between the Total Labor Force (in %) in Sub-Saharan Africa (all income levels) and Total Labor Force (in %) in Senegal?
Offer a terse response. -11.14. In the year 1997, what is the difference between the Total Labor Force (in %) of Sub-Saharan Africa (all income levels) and Total Labor Force (in %) of Trinidad and Tobago?
Ensure brevity in your answer.  -2.24. In the year 1997, what is the difference between the Total Labor Force (in %) of Benin and Total Labor Force (in %) of Senegal?
Your answer should be very brief. -4.7. In the year 1997, what is the difference between the Total Labor Force (in %) in Benin and Total Labor Force (in %) in Trinidad and Tobago?
Provide a succinct answer. 4.2. In the year 1997, what is the difference between the Total Labor Force (in %) of Senegal and Total Labor Force (in %) of Trinidad and Tobago?
Your answer should be very brief. 8.9. What is the ratio of the Total Labor Force (in %) of Benin in 1990 to that in 1991?
Make the answer very short. 1. What is the ratio of the Total Labor Force (in %) in Trinidad and Tobago in 1990 to that in 1991?
Provide a succinct answer. 1.15. What is the ratio of the Total Labor Force (in %) in Sub-Saharan Africa (all income levels) in 1990 to that in 1992?
Make the answer very short. 1.01. What is the ratio of the Total Labor Force (in %) of Trinidad and Tobago in 1990 to that in 1992?
Provide a succinct answer. 1.08. What is the ratio of the Total Labor Force (in %) in Sub-Saharan Africa (all income levels) in 1990 to that in 1993?
Keep it short and to the point. 1.01. What is the ratio of the Total Labor Force (in %) of Senegal in 1990 to that in 1993?
Your answer should be compact. 1. What is the ratio of the Total Labor Force (in %) in Trinidad and Tobago in 1990 to that in 1993?
Your answer should be compact. 1.03. What is the ratio of the Total Labor Force (in %) in Sub-Saharan Africa (all income levels) in 1990 to that in 1994?
Offer a terse response. 1.02. What is the ratio of the Total Labor Force (in %) of Benin in 1990 to that in 1994?
Offer a very short reply. 1.02. What is the ratio of the Total Labor Force (in %) in Senegal in 1990 to that in 1994?
Your answer should be compact. 1.01. What is the ratio of the Total Labor Force (in %) of Trinidad and Tobago in 1990 to that in 1994?
Your answer should be very brief. 1.01. What is the ratio of the Total Labor Force (in %) in Sub-Saharan Africa (all income levels) in 1990 to that in 1995?
Give a very brief answer. 1.02. What is the ratio of the Total Labor Force (in %) of Benin in 1990 to that in 1995?
Your answer should be very brief. 1.03. What is the ratio of the Total Labor Force (in %) of Sub-Saharan Africa (all income levels) in 1990 to that in 1996?
Keep it short and to the point. 1.02. What is the ratio of the Total Labor Force (in %) of Benin in 1990 to that in 1996?
Provide a succinct answer. 1.04. What is the ratio of the Total Labor Force (in %) of Senegal in 1990 to that in 1996?
Offer a very short reply. 1.01. What is the ratio of the Total Labor Force (in %) in Trinidad and Tobago in 1990 to that in 1996?
Your answer should be compact. 1.01. What is the ratio of the Total Labor Force (in %) of Sub-Saharan Africa (all income levels) in 1990 to that in 1997?
Provide a succinct answer. 1.03. What is the ratio of the Total Labor Force (in %) in Benin in 1990 to that in 1997?
Your answer should be compact. 1.06. What is the ratio of the Total Labor Force (in %) in Senegal in 1990 to that in 1997?
Ensure brevity in your answer.  1.01. What is the ratio of the Total Labor Force (in %) in Sub-Saharan Africa (all income levels) in 1991 to that in 1992?
Keep it short and to the point. 1. What is the ratio of the Total Labor Force (in %) of Benin in 1991 to that in 1992?
Your answer should be compact. 1. What is the ratio of the Total Labor Force (in %) in Trinidad and Tobago in 1991 to that in 1992?
Provide a succinct answer. 0.93. What is the ratio of the Total Labor Force (in %) of Sub-Saharan Africa (all income levels) in 1991 to that in 1993?
Offer a terse response. 1.01. What is the ratio of the Total Labor Force (in %) of Senegal in 1991 to that in 1993?
Provide a succinct answer. 1. What is the ratio of the Total Labor Force (in %) in Trinidad and Tobago in 1991 to that in 1993?
Provide a short and direct response. 0.89. What is the ratio of the Total Labor Force (in %) in Sub-Saharan Africa (all income levels) in 1991 to that in 1994?
Keep it short and to the point. 1.01. What is the ratio of the Total Labor Force (in %) of Benin in 1991 to that in 1994?
Your response must be concise. 1.02. What is the ratio of the Total Labor Force (in %) of Senegal in 1991 to that in 1994?
Provide a short and direct response. 1.01. What is the ratio of the Total Labor Force (in %) of Trinidad and Tobago in 1991 to that in 1994?
Provide a succinct answer. 0.88. What is the ratio of the Total Labor Force (in %) of Sub-Saharan Africa (all income levels) in 1991 to that in 1995?
Offer a very short reply. 1.01. What is the ratio of the Total Labor Force (in %) in Benin in 1991 to that in 1995?
Your answer should be compact. 1.03. What is the ratio of the Total Labor Force (in %) of Senegal in 1991 to that in 1995?
Offer a terse response. 1.01. What is the ratio of the Total Labor Force (in %) of Trinidad and Tobago in 1991 to that in 1995?
Your response must be concise. 0.87. What is the ratio of the Total Labor Force (in %) of Sub-Saharan Africa (all income levels) in 1991 to that in 1996?
Offer a very short reply. 1.02. What is the ratio of the Total Labor Force (in %) in Benin in 1991 to that in 1996?
Your answer should be very brief. 1.04. What is the ratio of the Total Labor Force (in %) of Trinidad and Tobago in 1991 to that in 1996?
Keep it short and to the point. 0.87. What is the ratio of the Total Labor Force (in %) of Sub-Saharan Africa (all income levels) in 1991 to that in 1997?
Your response must be concise. 1.02. What is the ratio of the Total Labor Force (in %) in Benin in 1991 to that in 1997?
Your answer should be very brief. 1.05. What is the ratio of the Total Labor Force (in %) of Senegal in 1991 to that in 1997?
Your response must be concise. 1.01. What is the ratio of the Total Labor Force (in %) of Trinidad and Tobago in 1991 to that in 1997?
Keep it short and to the point. 0.87. What is the ratio of the Total Labor Force (in %) of Trinidad and Tobago in 1992 to that in 1993?
Give a very brief answer. 0.96. What is the ratio of the Total Labor Force (in %) of Benin in 1992 to that in 1994?
Provide a short and direct response. 1.02. What is the ratio of the Total Labor Force (in %) in Senegal in 1992 to that in 1994?
Keep it short and to the point. 1. What is the ratio of the Total Labor Force (in %) of Trinidad and Tobago in 1992 to that in 1994?
Ensure brevity in your answer.  0.94. What is the ratio of the Total Labor Force (in %) in Sub-Saharan Africa (all income levels) in 1992 to that in 1995?
Make the answer very short. 1.01. What is the ratio of the Total Labor Force (in %) in Benin in 1992 to that in 1995?
Keep it short and to the point. 1.03. What is the ratio of the Total Labor Force (in %) in Trinidad and Tobago in 1992 to that in 1995?
Provide a short and direct response. 0.93. What is the ratio of the Total Labor Force (in %) of Sub-Saharan Africa (all income levels) in 1992 to that in 1996?
Provide a succinct answer. 1.01. What is the ratio of the Total Labor Force (in %) in Benin in 1992 to that in 1996?
Provide a succinct answer. 1.04. What is the ratio of the Total Labor Force (in %) in Senegal in 1992 to that in 1996?
Offer a very short reply. 1.01. What is the ratio of the Total Labor Force (in %) in Trinidad and Tobago in 1992 to that in 1996?
Your answer should be compact. 0.94. What is the ratio of the Total Labor Force (in %) of Sub-Saharan Africa (all income levels) in 1992 to that in 1997?
Your answer should be compact. 1.02. What is the ratio of the Total Labor Force (in %) of Benin in 1992 to that in 1997?
Make the answer very short. 1.05. What is the ratio of the Total Labor Force (in %) in Senegal in 1992 to that in 1997?
Provide a succinct answer. 1.01. What is the ratio of the Total Labor Force (in %) in Trinidad and Tobago in 1992 to that in 1997?
Your answer should be very brief. 0.93. What is the ratio of the Total Labor Force (in %) in Sub-Saharan Africa (all income levels) in 1993 to that in 1994?
Your answer should be compact. 1. What is the ratio of the Total Labor Force (in %) in Benin in 1993 to that in 1994?
Your answer should be compact. 1.01. What is the ratio of the Total Labor Force (in %) of Senegal in 1993 to that in 1994?
Give a very brief answer. 1. What is the ratio of the Total Labor Force (in %) of Trinidad and Tobago in 1993 to that in 1994?
Ensure brevity in your answer.  0.98. What is the ratio of the Total Labor Force (in %) of Sub-Saharan Africa (all income levels) in 1993 to that in 1995?
Your answer should be compact. 1.01. What is the ratio of the Total Labor Force (in %) in Benin in 1993 to that in 1995?
Ensure brevity in your answer.  1.02. What is the ratio of the Total Labor Force (in %) of Sub-Saharan Africa (all income levels) in 1993 to that in 1996?
Keep it short and to the point. 1.01. What is the ratio of the Total Labor Force (in %) in Benin in 1993 to that in 1996?
Give a very brief answer. 1.03. What is the ratio of the Total Labor Force (in %) of Senegal in 1993 to that in 1996?
Offer a very short reply. 1. What is the ratio of the Total Labor Force (in %) in Trinidad and Tobago in 1993 to that in 1996?
Your answer should be very brief. 0.98. What is the ratio of the Total Labor Force (in %) in Sub-Saharan Africa (all income levels) in 1993 to that in 1997?
Offer a terse response. 1.01. What is the ratio of the Total Labor Force (in %) in Benin in 1993 to that in 1997?
Your answer should be compact. 1.04. What is the ratio of the Total Labor Force (in %) of Senegal in 1993 to that in 1997?
Provide a succinct answer. 1.01. What is the ratio of the Total Labor Force (in %) of Trinidad and Tobago in 1993 to that in 1997?
Provide a succinct answer. 0.97. What is the ratio of the Total Labor Force (in %) of Sub-Saharan Africa (all income levels) in 1994 to that in 1995?
Offer a terse response. 1. What is the ratio of the Total Labor Force (in %) in Benin in 1994 to that in 1995?
Your response must be concise. 1.01. What is the ratio of the Total Labor Force (in %) of Senegal in 1994 to that in 1995?
Provide a short and direct response. 1. What is the ratio of the Total Labor Force (in %) in Sub-Saharan Africa (all income levels) in 1994 to that in 1996?
Ensure brevity in your answer.  1.01. What is the ratio of the Total Labor Force (in %) in Benin in 1994 to that in 1996?
Your answer should be compact. 1.02. What is the ratio of the Total Labor Force (in %) in Senegal in 1994 to that in 1996?
Ensure brevity in your answer.  1. What is the ratio of the Total Labor Force (in %) in Sub-Saharan Africa (all income levels) in 1994 to that in 1997?
Ensure brevity in your answer.  1.01. What is the ratio of the Total Labor Force (in %) of Benin in 1994 to that in 1997?
Provide a succinct answer. 1.03. What is the ratio of the Total Labor Force (in %) in Trinidad and Tobago in 1994 to that in 1997?
Provide a short and direct response. 0.99. What is the ratio of the Total Labor Force (in %) in Benin in 1995 to that in 1996?
Make the answer very short. 1.01. What is the ratio of the Total Labor Force (in %) of Trinidad and Tobago in 1995 to that in 1996?
Your answer should be very brief. 1. What is the ratio of the Total Labor Force (in %) in Benin in 1995 to that in 1997?
Make the answer very short. 1.02. What is the ratio of the Total Labor Force (in %) of Senegal in 1995 to that in 1997?
Offer a terse response. 1. What is the ratio of the Total Labor Force (in %) of Trinidad and Tobago in 1995 to that in 1997?
Your answer should be compact. 1. What is the ratio of the Total Labor Force (in %) of Benin in 1996 to that in 1997?
Ensure brevity in your answer.  1.01. What is the difference between the highest and the second highest Total Labor Force (in %) of Sub-Saharan Africa (all income levels)?
Give a very brief answer. 0.31. What is the difference between the highest and the second highest Total Labor Force (in %) of Benin?
Keep it short and to the point. 0.1. What is the difference between the highest and the second highest Total Labor Force (in %) in Trinidad and Tobago?
Your response must be concise. 0.2. What is the difference between the highest and the lowest Total Labor Force (in %) in Sub-Saharan Africa (all income levels)?
Ensure brevity in your answer.  2.07. What is the difference between the highest and the lowest Total Labor Force (in %) of Benin?
Make the answer very short. 4.7. What is the difference between the highest and the lowest Total Labor Force (in %) in Senegal?
Your response must be concise. 0.9. 